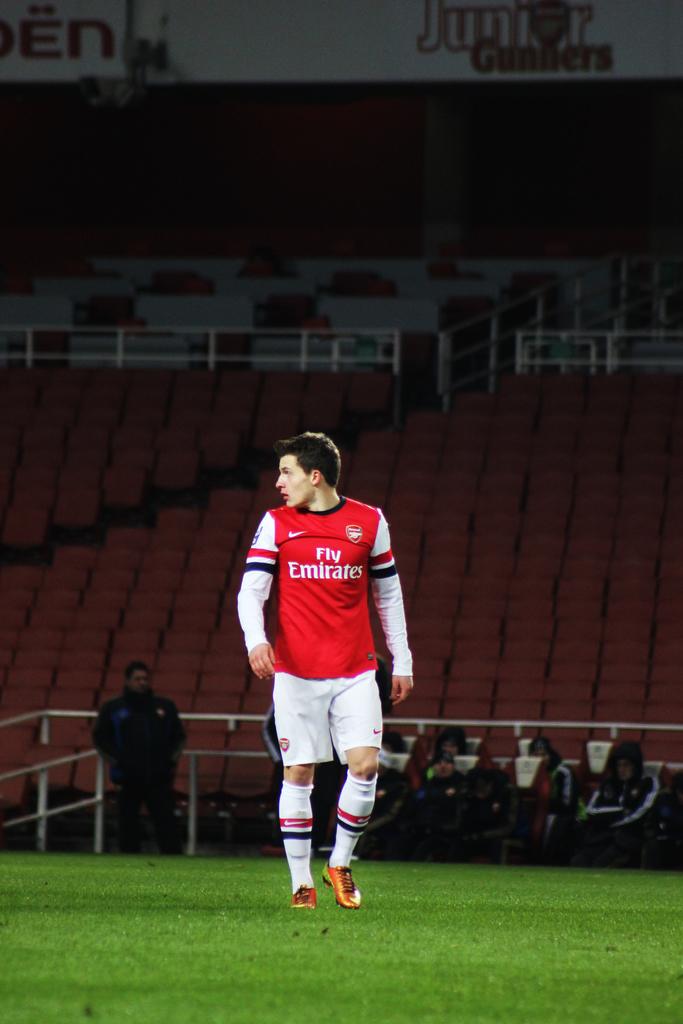What team is playing?
Make the answer very short. Unanswerable. 